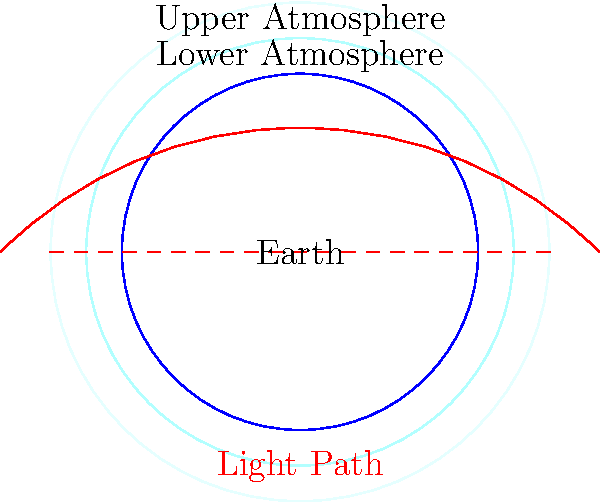In the diagram above, a beam of light travels through the Earth's atmosphere. How does non-Euclidean geometry explain the curved path of light compared to the expected straight line in Euclidean space? Consider the relationship between atmospheric density and the speed of light in your answer. To understand how non-Euclidean geometry affects the path of light through different atmospheric layers, we need to follow these steps:

1. Recognize that the Earth's atmosphere is not uniform:
   The density of the atmosphere decreases with altitude, creating layers with different refractive indices.

2. Understand the relationship between refractive index and light speed:
   $$v = \frac{c}{n}$$
   where $v$ is the speed of light in the medium, $c$ is the speed of light in vacuum, and $n$ is the refractive index.

3. Apply Fermat's principle:
   Light travels along the path that takes the least time, not necessarily the shortest distance.

4. Consider the curved space-time in non-Euclidean geometry:
   The varying density of the atmosphere creates a curved space, which can be described using non-Euclidean geometry.

5. Analyze the light path:
   In this curved space, the "straight line" (geodesic) that minimizes travel time is actually a curve when projected onto Euclidean space.

6. Compare with Snell's law:
   The continuous bending of light in the atmosphere is analogous to a series of tiny refractions described by Snell's law:
   $$n_1 \sin \theta_1 = n_2 \sin \theta_2$$

7. Relate to storm chasing:
   Understanding this phenomenon is crucial for accurately interpreting atmospheric observations, especially when tracking storms or analyzing weather patterns at different altitudes.

In conclusion, non-Euclidean geometry provides a framework to describe the curved path of light through the atmosphere as a straight line (geodesic) in a curved space, reconciling the observed behavior with the principle of least time.
Answer: Non-Euclidean geometry describes the atmosphere as a curved space where the geodesic (shortest path) appears curved in Euclidean projection due to varying atmospheric density. 